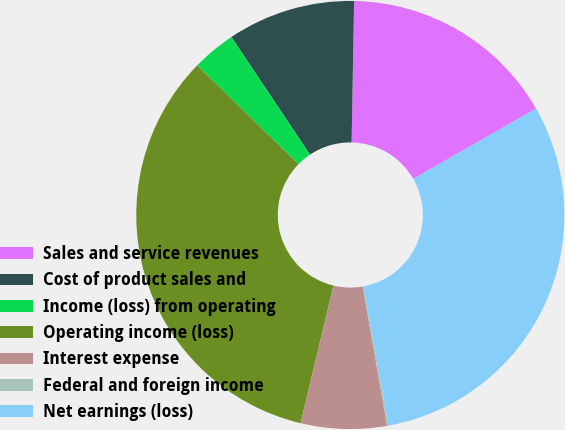Convert chart. <chart><loc_0><loc_0><loc_500><loc_500><pie_chart><fcel>Sales and service revenues<fcel>Cost of product sales and<fcel>Income (loss) from operating<fcel>Operating income (loss)<fcel>Interest expense<fcel>Federal and foreign income<fcel>Net earnings (loss)<nl><fcel>16.44%<fcel>9.66%<fcel>3.3%<fcel>33.59%<fcel>6.48%<fcel>0.12%<fcel>30.41%<nl></chart> 